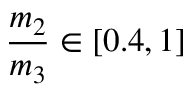<formula> <loc_0><loc_0><loc_500><loc_500>\frac { m _ { 2 } } { m _ { 3 } } \in [ 0 . 4 , 1 ]</formula> 